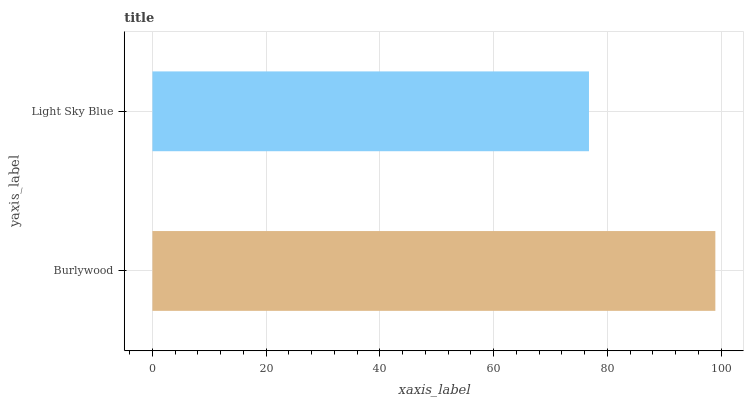Is Light Sky Blue the minimum?
Answer yes or no. Yes. Is Burlywood the maximum?
Answer yes or no. Yes. Is Light Sky Blue the maximum?
Answer yes or no. No. Is Burlywood greater than Light Sky Blue?
Answer yes or no. Yes. Is Light Sky Blue less than Burlywood?
Answer yes or no. Yes. Is Light Sky Blue greater than Burlywood?
Answer yes or no. No. Is Burlywood less than Light Sky Blue?
Answer yes or no. No. Is Burlywood the high median?
Answer yes or no. Yes. Is Light Sky Blue the low median?
Answer yes or no. Yes. Is Light Sky Blue the high median?
Answer yes or no. No. Is Burlywood the low median?
Answer yes or no. No. 